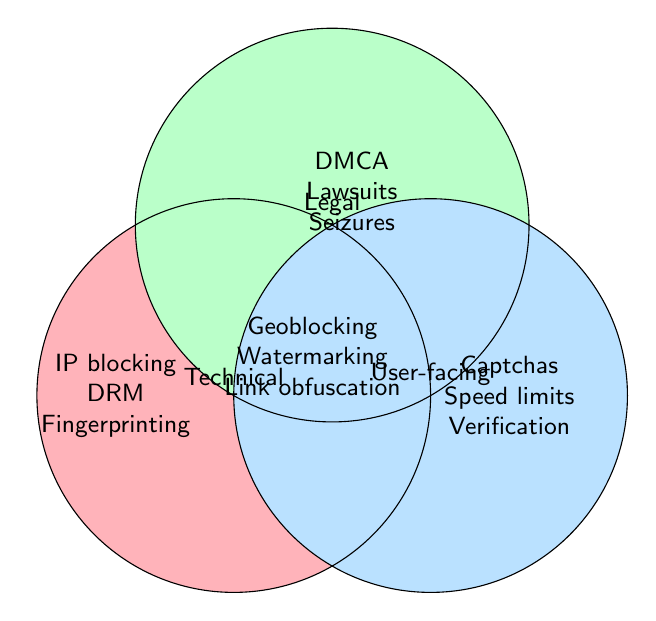What are the common anti-piracy measures that are used in both Technical and Legal categories? This question asks for measures that fall into both Technical and Legal categories. However, the figure shows no overlap between these two individual categories.
Answer: None Which anti-piracy measure is unique to the User-facing category and involves speed limitations? Look into the User-facing section. It points out measures like Captchas, Limited download speeds, and Account verification. The unique measure involving speed limitations is 'Limited download speeds.'
Answer: Limited download speeds What measures do all categories share in common? The center of the Venn Diagram, where all three circles overlap, represents common measures for all categories. These measures include Geoblocking, Watermarking, and Link obfuscation.
Answer: Geoblocking, Watermarking, Link obfuscation How many unique measures are listed in the Technical category? Count the independent measures listed in the Technical section: IP blocking, Content fingerprinting, DRM, and Encrypted streams. That makes four measures.
Answer: Four Are DMCA takedown notices relevant only to the Legal category? Identify which circle DMCA takedown notices fall into. It is only in the Legal section, indicating it is exclusively a Legal measure.
Answer: Yes Which category encompasses 'Account verification'? Find 'Account verification' within the Venn Diagram, confirming it lies in the User-facing circle.
Answer: User-facing Compare the Drug fingerprinting measure with the other technical measures using another user-facing measure for reference; is a highly secure as the other techniques? Compare fingerprinting measure (Technical) considering context control measure (User-facing). Despite encryption differences all provide barriers against unauthorized distribution
Answer: Encrypted streams Do any measures relate to 'watermarking' user-drawn legal/technical sphere comparsion? Watermarking effects common are used across Technical, Legal, and User-facing indicating importance across these contexts
Answer: Impacts all 